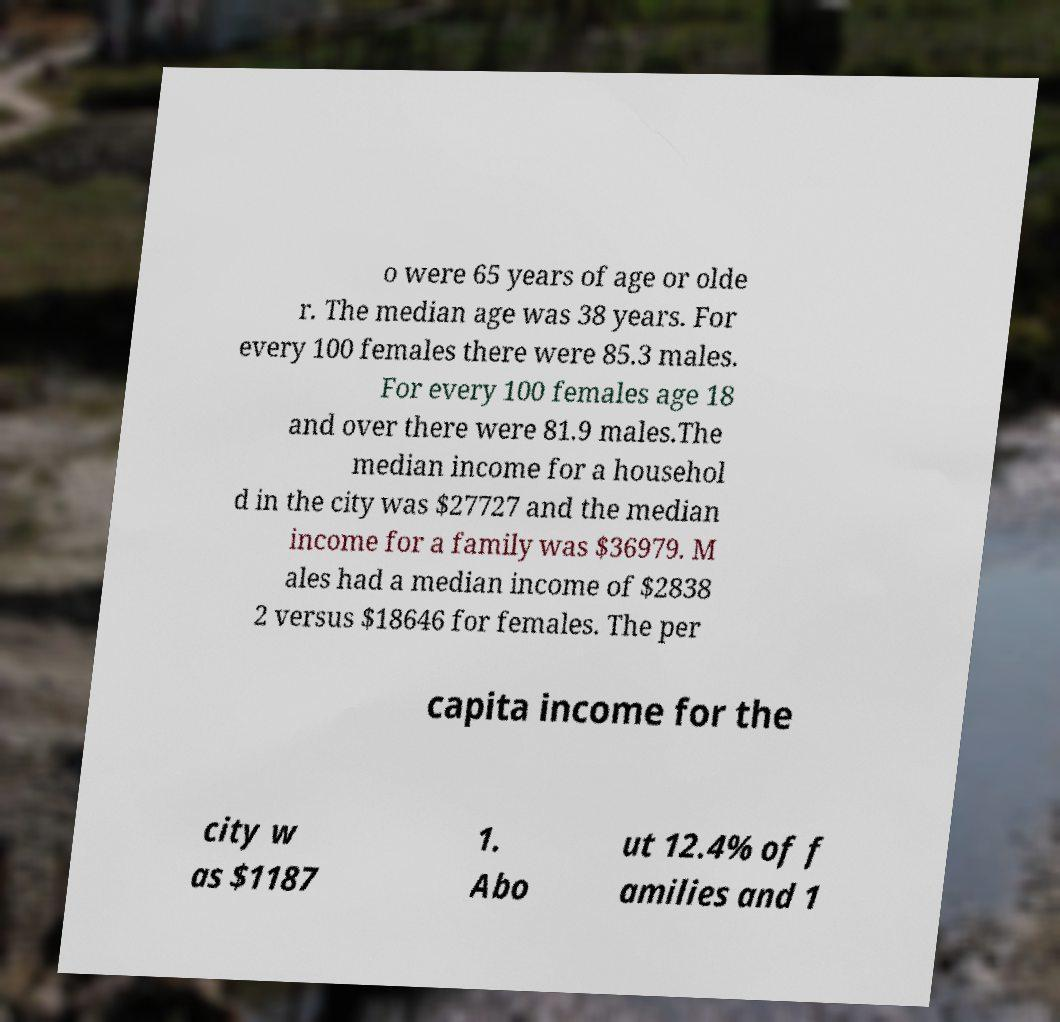What messages or text are displayed in this image? I need them in a readable, typed format. o were 65 years of age or olde r. The median age was 38 years. For every 100 females there were 85.3 males. For every 100 females age 18 and over there were 81.9 males.The median income for a househol d in the city was $27727 and the median income for a family was $36979. M ales had a median income of $2838 2 versus $18646 for females. The per capita income for the city w as $1187 1. Abo ut 12.4% of f amilies and 1 